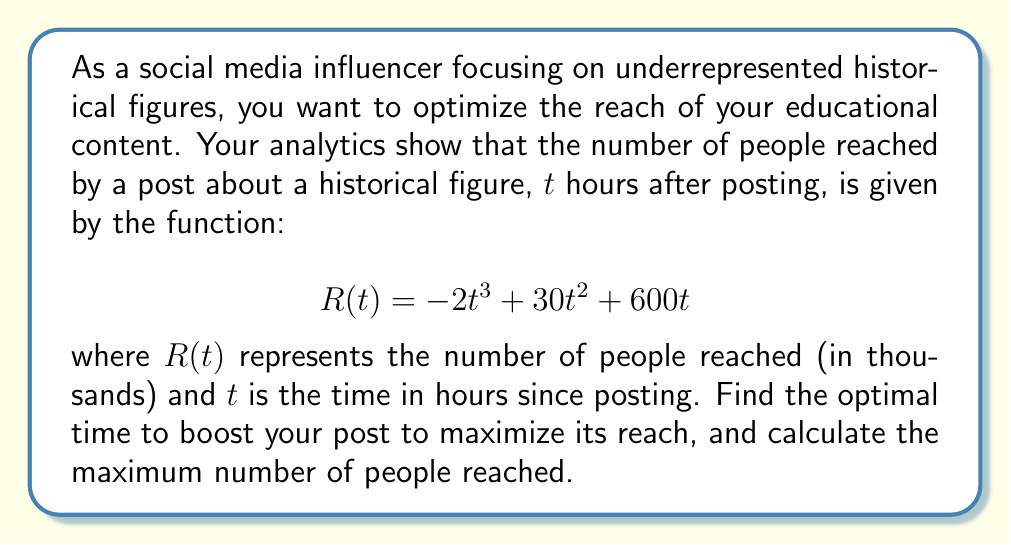Could you help me with this problem? To find the optimal time and maximum reach, we need to find the maximum of the function $R(t)$. We can do this by following these steps:

1) First, we find the derivative of $R(t)$:
   $$R'(t) = -6t^2 + 60t + 600$$

2) To find the critical points, we set $R'(t) = 0$:
   $$-6t^2 + 60t + 600 = 0$$

3) This is a quadratic equation. We can solve it using the quadratic formula:
   $$t = \frac{-b \pm \sqrt{b^2 - 4ac}}{2a}$$
   where $a = -6$, $b = 60$, and $c = 600$

4) Plugging in these values:
   $$t = \frac{-60 \pm \sqrt{60^2 - 4(-6)(600)}}{2(-6)}$$
   $$= \frac{-60 \pm \sqrt{3600 + 14400}}{-12}$$
   $$= \frac{-60 \pm \sqrt{18000}}{-12}$$
   $$= \frac{-60 \pm 134.16}{-12}$$

5) This gives us two solutions:
   $t_1 = \frac{-60 + 134.16}{-12} \approx 6.18$ hours
   $t_2 = \frac{-60 - 134.16}{-12} \approx 16.18$ hours

6) To determine which of these gives the maximum, we can use the second derivative test:
   $$R''(t) = -12t + 60$$

7) Evaluating $R''(t)$ at $t_1 = 6.18$:
   $R''(6.18) = -12(6.18) + 60 \approx -14.16 < 0$

   This confirms that $t_1 = 6.18$ hours gives a local maximum.

8) To find the maximum reach, we plug $t = 6.18$ back into our original function:
   $$R(6.18) = -2(6.18)^3 + 30(6.18)^2 + 600(6.18) \approx 3,395.51$$

Therefore, the optimal time to boost the post is approximately 6.18 hours after posting, and at this time, the post will reach about 3,395,510 people.
Answer: Optimal time: 6.18 hours; Maximum reach: 3,395,510 people 